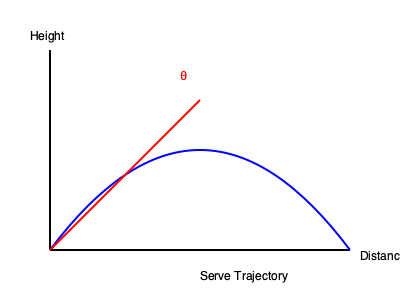Given that a tennis serve's trajectory can be approximated by a parabolic curve, how does increasing the serve angle (θ) affect the serve's peak height and overall distance, and what strategic implications does this have for your game against a mentally strong opponent? To analyze the serve trajectory and its strategic implications:

1. Trajectory shape: The serve follows a parabolic path, represented by the blue curve.

2. Angle effect on height:
   - As θ increases, the peak height of the serve increases.
   - This is because $h_{max} = \frac{v_0^2 \sin^2 θ}{2g}$, where $v_0$ is initial velocity and $g$ is gravitational acceleration.

3. Angle effect on distance:
   - The total horizontal distance (range) is given by $R = \frac{v_0^2 \sin 2θ}{g}$.
   - Maximum range occurs at θ = 45°.

4. Strategic implications:
   a) Higher angle (steeper serve):
      - Increases peak height, making it harder for opponent to reach.
      - Reduces horizontal distance, potentially limiting court placement options.
      - More time for the ball to drop, allowing for more spin.

   b) Lower angle (flatter serve):
      - Decreases peak height, making it easier to reach but faster.
      - Increases horizontal distance, allowing for deeper court placement.
      - Less time for the ball to drop, reducing potential spin.

5. Against a mentally strong opponent:
   - Vary serve angles to keep them guessing and prevent adaptation.
   - Use steeper serves for more spin and to test their ability to handle high bounces.
   - Employ flatter serves for speed and to pressure their reaction time.
   - Strategically alternate between serve types to maintain pressure and exploit any weaknesses in their mental game.

6. Optimal strategy:
   - Find a balance between angle, speed, and spin that maximizes your strengths and exploits opponent weaknesses.
   - Adapt your serve strategy based on the opponent's responses and mental state throughout the match.
Answer: Increasing serve angle increases peak height but decreases range; strategically vary angles to challenge opponent's mental strength and adaptability. 